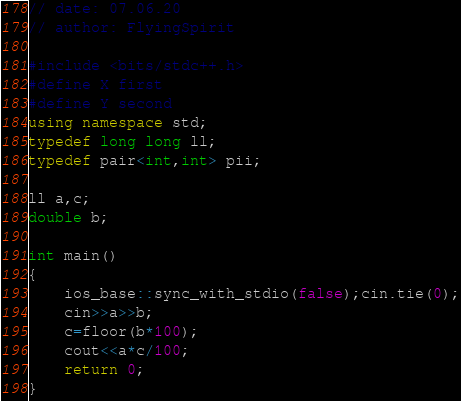<code> <loc_0><loc_0><loc_500><loc_500><_C++_>// date: 07.06.20
// author: FlyingSpirit

#include <bits/stdc++.h>
#define X first
#define Y second
using namespace std;
typedef long long ll;
typedef pair<int,int> pii;

ll a,c;
double b;

int main()
{
    ios_base::sync_with_stdio(false);cin.tie(0);
    cin>>a>>b;
    c=floor(b*100);
    cout<<a*c/100;
    return 0;
}
</code> 